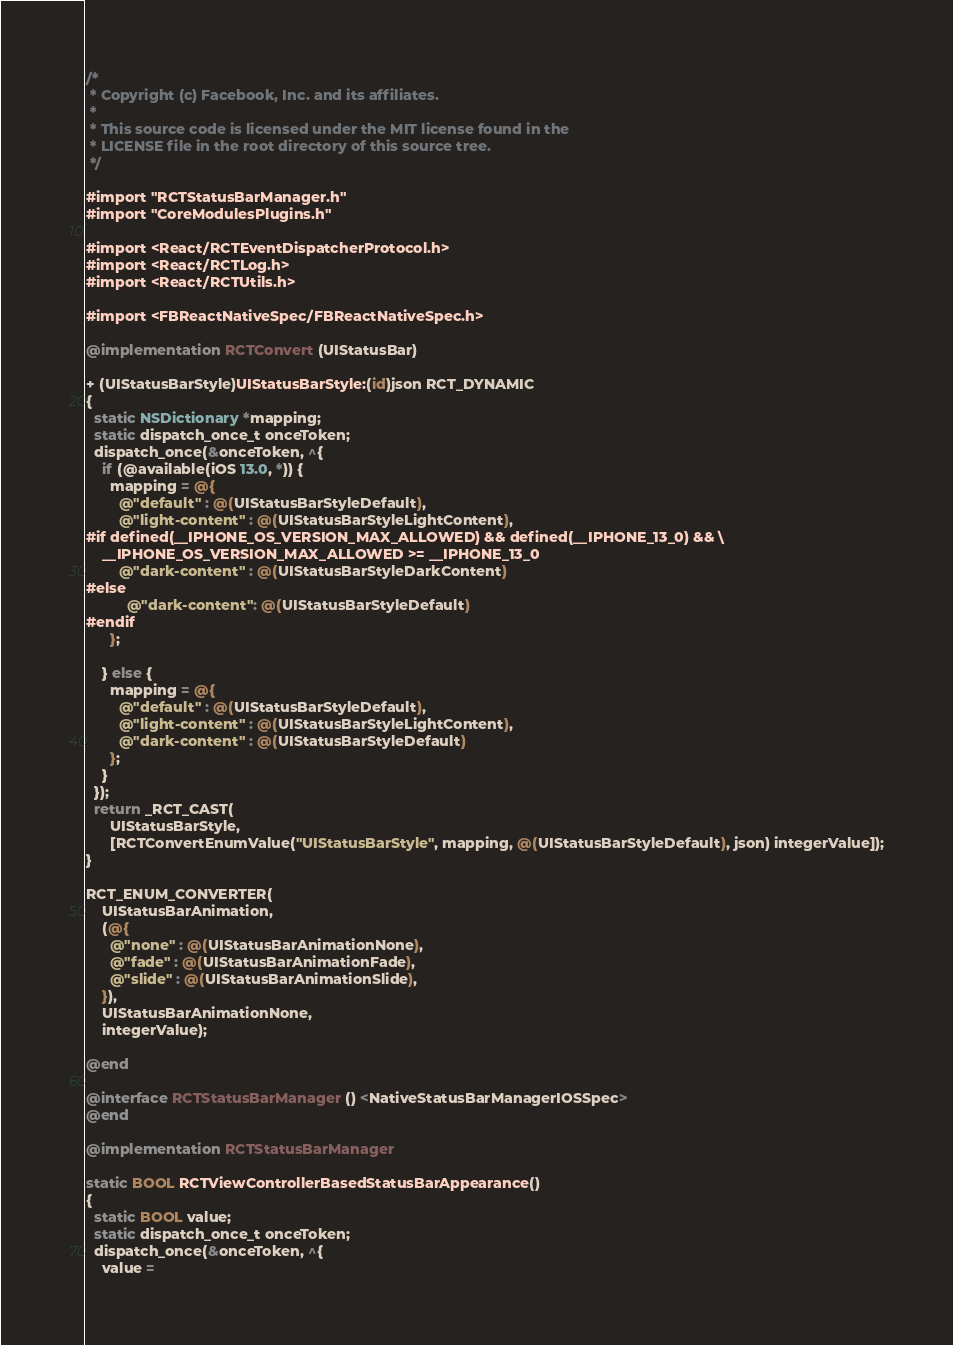<code> <loc_0><loc_0><loc_500><loc_500><_ObjectiveC_>/*
 * Copyright (c) Facebook, Inc. and its affiliates.
 *
 * This source code is licensed under the MIT license found in the
 * LICENSE file in the root directory of this source tree.
 */

#import "RCTStatusBarManager.h"
#import "CoreModulesPlugins.h"

#import <React/RCTEventDispatcherProtocol.h>
#import <React/RCTLog.h>
#import <React/RCTUtils.h>

#import <FBReactNativeSpec/FBReactNativeSpec.h>

@implementation RCTConvert (UIStatusBar)

+ (UIStatusBarStyle)UIStatusBarStyle:(id)json RCT_DYNAMIC
{
  static NSDictionary *mapping;
  static dispatch_once_t onceToken;
  dispatch_once(&onceToken, ^{
    if (@available(iOS 13.0, *)) {
      mapping = @{
        @"default" : @(UIStatusBarStyleDefault),
        @"light-content" : @(UIStatusBarStyleLightContent),
#if defined(__IPHONE_OS_VERSION_MAX_ALLOWED) && defined(__IPHONE_13_0) && \
    __IPHONE_OS_VERSION_MAX_ALLOWED >= __IPHONE_13_0
        @"dark-content" : @(UIStatusBarStyleDarkContent)
#else
          @"dark-content": @(UIStatusBarStyleDefault)
#endif
      };

    } else {
      mapping = @{
        @"default" : @(UIStatusBarStyleDefault),
        @"light-content" : @(UIStatusBarStyleLightContent),
        @"dark-content" : @(UIStatusBarStyleDefault)
      };
    }
  });
  return _RCT_CAST(
      UIStatusBarStyle,
      [RCTConvertEnumValue("UIStatusBarStyle", mapping, @(UIStatusBarStyleDefault), json) integerValue]);
}

RCT_ENUM_CONVERTER(
    UIStatusBarAnimation,
    (@{
      @"none" : @(UIStatusBarAnimationNone),
      @"fade" : @(UIStatusBarAnimationFade),
      @"slide" : @(UIStatusBarAnimationSlide),
    }),
    UIStatusBarAnimationNone,
    integerValue);

@end

@interface RCTStatusBarManager () <NativeStatusBarManagerIOSSpec>
@end

@implementation RCTStatusBarManager

static BOOL RCTViewControllerBasedStatusBarAppearance()
{
  static BOOL value;
  static dispatch_once_t onceToken;
  dispatch_once(&onceToken, ^{
    value =</code> 